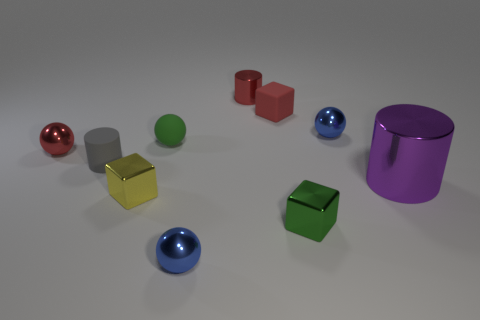What number of large objects have the same color as the rubber cube?
Keep it short and to the point. 0. Is the number of small cylinders that are in front of the small metallic cylinder less than the number of blocks behind the green sphere?
Make the answer very short. No. What size is the ball that is in front of the big purple cylinder?
Keep it short and to the point. Small. What size is the metal object that is the same color as the tiny shiny cylinder?
Your answer should be very brief. Small. Are there any large cylinders made of the same material as the large object?
Your response must be concise. No. Is the green block made of the same material as the large purple thing?
Provide a succinct answer. Yes. There is a matte cylinder that is the same size as the matte ball; what color is it?
Offer a very short reply. Gray. What number of other objects are there of the same shape as the purple thing?
Keep it short and to the point. 2. Does the purple shiny cylinder have the same size as the blue metal sphere right of the red metallic cylinder?
Make the answer very short. No. How many things are big red shiny cubes or green metallic objects?
Provide a succinct answer. 1. 